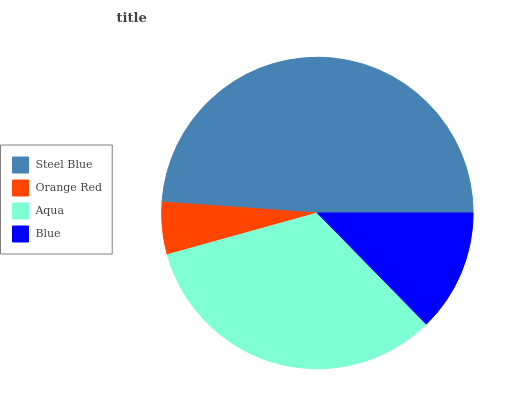Is Orange Red the minimum?
Answer yes or no. Yes. Is Steel Blue the maximum?
Answer yes or no. Yes. Is Aqua the minimum?
Answer yes or no. No. Is Aqua the maximum?
Answer yes or no. No. Is Aqua greater than Orange Red?
Answer yes or no. Yes. Is Orange Red less than Aqua?
Answer yes or no. Yes. Is Orange Red greater than Aqua?
Answer yes or no. No. Is Aqua less than Orange Red?
Answer yes or no. No. Is Aqua the high median?
Answer yes or no. Yes. Is Blue the low median?
Answer yes or no. Yes. Is Orange Red the high median?
Answer yes or no. No. Is Steel Blue the low median?
Answer yes or no. No. 